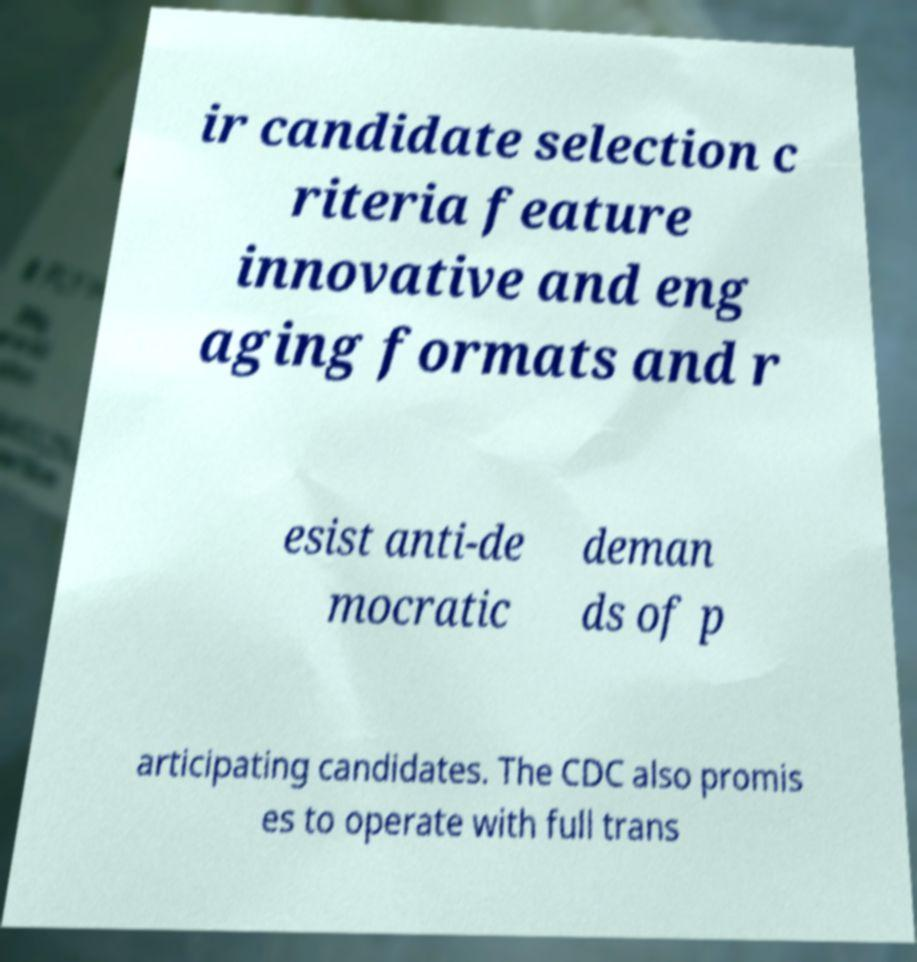What messages or text are displayed in this image? I need them in a readable, typed format. ir candidate selection c riteria feature innovative and eng aging formats and r esist anti-de mocratic deman ds of p articipating candidates. The CDC also promis es to operate with full trans 